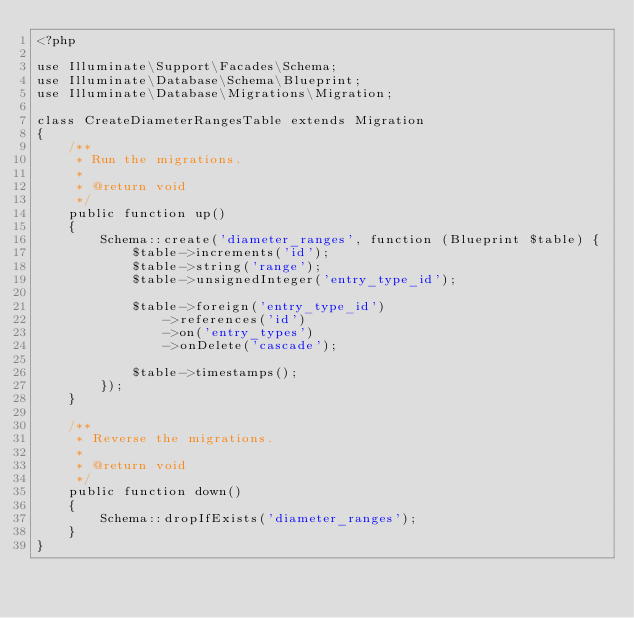Convert code to text. <code><loc_0><loc_0><loc_500><loc_500><_PHP_><?php

use Illuminate\Support\Facades\Schema;
use Illuminate\Database\Schema\Blueprint;
use Illuminate\Database\Migrations\Migration;

class CreateDiameterRangesTable extends Migration
{
    /**
     * Run the migrations.
     *
     * @return void
     */
    public function up()
    {
        Schema::create('diameter_ranges', function (Blueprint $table) {
            $table->increments('id');
            $table->string('range');
            $table->unsignedInteger('entry_type_id');

            $table->foreign('entry_type_id')
                ->references('id')
                ->on('entry_types')
                ->onDelete('cascade');

            $table->timestamps();
        });
    }

    /**
     * Reverse the migrations.
     *
     * @return void
     */
    public function down()
    {
        Schema::dropIfExists('diameter_ranges');
    }
}
</code> 